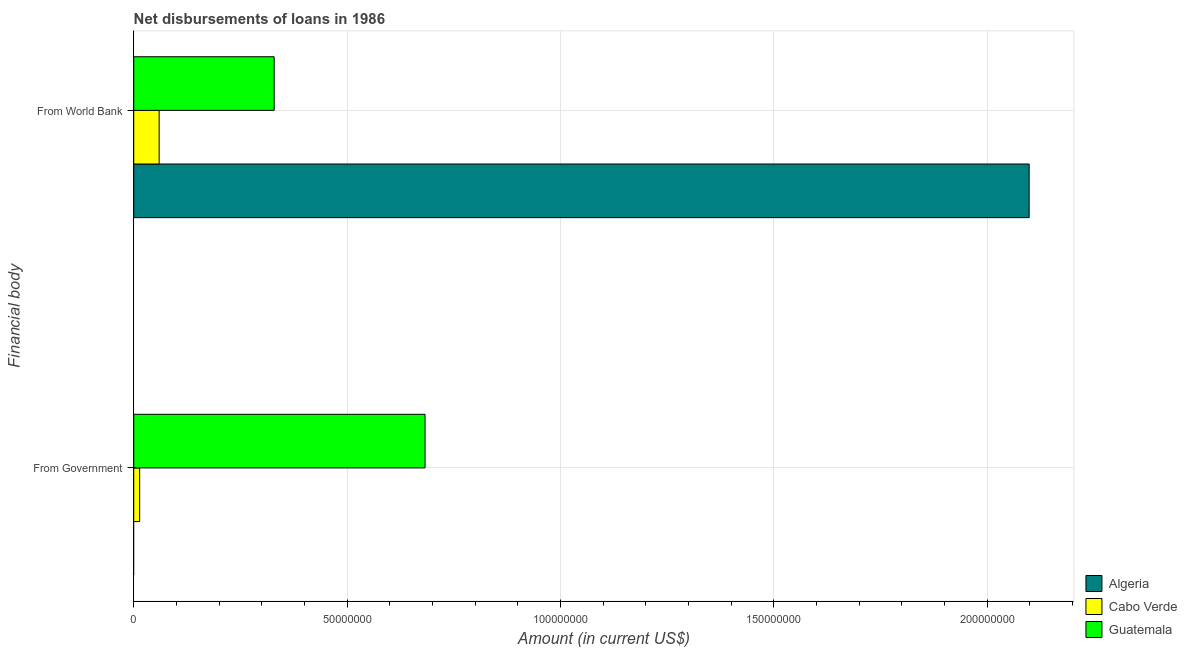How many different coloured bars are there?
Offer a terse response. 3. How many groups of bars are there?
Make the answer very short. 2. Are the number of bars on each tick of the Y-axis equal?
Your answer should be very brief. No. What is the label of the 2nd group of bars from the top?
Give a very brief answer. From Government. What is the net disbursements of loan from government in Guatemala?
Provide a short and direct response. 6.83e+07. Across all countries, what is the maximum net disbursements of loan from world bank?
Offer a very short reply. 2.10e+08. In which country was the net disbursements of loan from world bank maximum?
Provide a short and direct response. Algeria. What is the total net disbursements of loan from government in the graph?
Give a very brief answer. 6.97e+07. What is the difference between the net disbursements of loan from world bank in Guatemala and that in Algeria?
Offer a terse response. -1.77e+08. What is the difference between the net disbursements of loan from world bank in Guatemala and the net disbursements of loan from government in Cabo Verde?
Make the answer very short. 3.15e+07. What is the average net disbursements of loan from government per country?
Make the answer very short. 2.32e+07. What is the difference between the net disbursements of loan from government and net disbursements of loan from world bank in Guatemala?
Your answer should be very brief. 3.54e+07. What is the ratio of the net disbursements of loan from world bank in Guatemala to that in Cabo Verde?
Your response must be concise. 5.53. Is the net disbursements of loan from world bank in Cabo Verde less than that in Algeria?
Offer a very short reply. Yes. In how many countries, is the net disbursements of loan from world bank greater than the average net disbursements of loan from world bank taken over all countries?
Make the answer very short. 1. How many countries are there in the graph?
Keep it short and to the point. 3. What is the difference between two consecutive major ticks on the X-axis?
Your answer should be compact. 5.00e+07. Where does the legend appear in the graph?
Make the answer very short. Bottom right. How many legend labels are there?
Give a very brief answer. 3. What is the title of the graph?
Your response must be concise. Net disbursements of loans in 1986. Does "Liechtenstein" appear as one of the legend labels in the graph?
Offer a terse response. No. What is the label or title of the Y-axis?
Your answer should be compact. Financial body. What is the Amount (in current US$) of Cabo Verde in From Government?
Offer a very short reply. 1.39e+06. What is the Amount (in current US$) in Guatemala in From Government?
Provide a succinct answer. 6.83e+07. What is the Amount (in current US$) of Algeria in From World Bank?
Make the answer very short. 2.10e+08. What is the Amount (in current US$) of Cabo Verde in From World Bank?
Your response must be concise. 5.95e+06. What is the Amount (in current US$) of Guatemala in From World Bank?
Give a very brief answer. 3.29e+07. Across all Financial body, what is the maximum Amount (in current US$) in Algeria?
Your response must be concise. 2.10e+08. Across all Financial body, what is the maximum Amount (in current US$) of Cabo Verde?
Give a very brief answer. 5.95e+06. Across all Financial body, what is the maximum Amount (in current US$) of Guatemala?
Ensure brevity in your answer.  6.83e+07. Across all Financial body, what is the minimum Amount (in current US$) in Algeria?
Ensure brevity in your answer.  0. Across all Financial body, what is the minimum Amount (in current US$) in Cabo Verde?
Provide a short and direct response. 1.39e+06. Across all Financial body, what is the minimum Amount (in current US$) in Guatemala?
Offer a terse response. 3.29e+07. What is the total Amount (in current US$) in Algeria in the graph?
Your answer should be very brief. 2.10e+08. What is the total Amount (in current US$) in Cabo Verde in the graph?
Ensure brevity in your answer.  7.34e+06. What is the total Amount (in current US$) in Guatemala in the graph?
Give a very brief answer. 1.01e+08. What is the difference between the Amount (in current US$) of Cabo Verde in From Government and that in From World Bank?
Your response must be concise. -4.56e+06. What is the difference between the Amount (in current US$) in Guatemala in From Government and that in From World Bank?
Offer a very short reply. 3.54e+07. What is the difference between the Amount (in current US$) of Cabo Verde in From Government and the Amount (in current US$) of Guatemala in From World Bank?
Your answer should be compact. -3.15e+07. What is the average Amount (in current US$) in Algeria per Financial body?
Provide a succinct answer. 1.05e+08. What is the average Amount (in current US$) of Cabo Verde per Financial body?
Offer a terse response. 3.67e+06. What is the average Amount (in current US$) of Guatemala per Financial body?
Provide a succinct answer. 5.06e+07. What is the difference between the Amount (in current US$) of Cabo Verde and Amount (in current US$) of Guatemala in From Government?
Provide a short and direct response. -6.69e+07. What is the difference between the Amount (in current US$) of Algeria and Amount (in current US$) of Cabo Verde in From World Bank?
Make the answer very short. 2.04e+08. What is the difference between the Amount (in current US$) in Algeria and Amount (in current US$) in Guatemala in From World Bank?
Ensure brevity in your answer.  1.77e+08. What is the difference between the Amount (in current US$) of Cabo Verde and Amount (in current US$) of Guatemala in From World Bank?
Provide a succinct answer. -2.70e+07. What is the ratio of the Amount (in current US$) of Cabo Verde in From Government to that in From World Bank?
Provide a succinct answer. 0.23. What is the ratio of the Amount (in current US$) in Guatemala in From Government to that in From World Bank?
Ensure brevity in your answer.  2.07. What is the difference between the highest and the second highest Amount (in current US$) in Cabo Verde?
Keep it short and to the point. 4.56e+06. What is the difference between the highest and the second highest Amount (in current US$) of Guatemala?
Offer a very short reply. 3.54e+07. What is the difference between the highest and the lowest Amount (in current US$) in Algeria?
Provide a short and direct response. 2.10e+08. What is the difference between the highest and the lowest Amount (in current US$) of Cabo Verde?
Your response must be concise. 4.56e+06. What is the difference between the highest and the lowest Amount (in current US$) of Guatemala?
Give a very brief answer. 3.54e+07. 